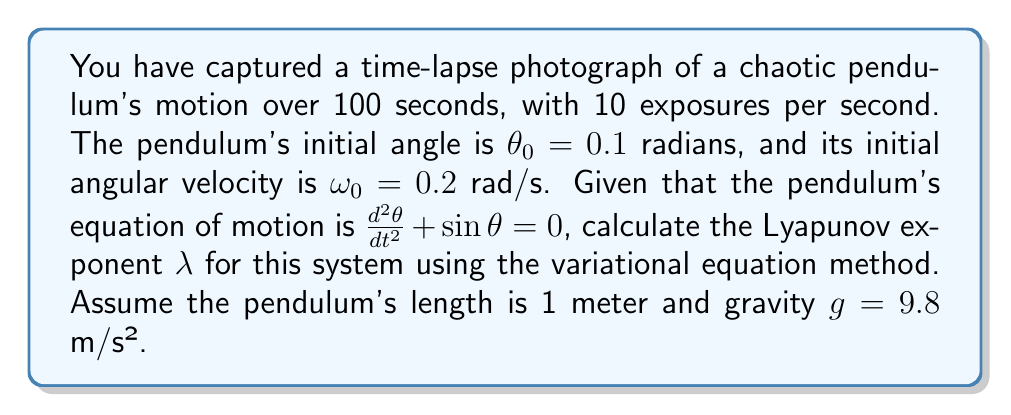Provide a solution to this math problem. To calculate the Lyapunov exponent for the chaotic pendulum:

1. Write the system of first-order differential equations:
   $$\frac{d\theta}{dt} = \omega$$
   $$\frac{d\omega}{dt} = -\sin\theta$$

2. Derive the variational equation:
   $$\frac{d}{dt}\begin{pmatrix}\delta\theta \\ \delta\omega\end{pmatrix} = \begin{pmatrix}0 & 1 \\ -\cos\theta & 0\end{pmatrix}\begin{pmatrix}\delta\theta \\ \delta\omega\end{pmatrix}$$

3. Solve the system numerically using a method like Runge-Kutta for the given time interval (100 seconds) with initial conditions $\theta_0 = 0.1$ and $\omega_0 = 0.2$.

4. Simultaneously solve the variational equation with initial condition $\begin{pmatrix}\delta\theta_0 \\ \delta\omega_0\end{pmatrix} = \begin{pmatrix}1 \\ 0\end{pmatrix}$.

5. Calculate the Lyapunov exponent using:
   $$\lambda = \lim_{t\to\infty} \frac{1}{t} \ln\left(\frac{\|\delta\vec{x}(t)\|}{\|\delta\vec{x}(0)\|}\right)$$

   where $\delta\vec{x}(t) = \begin{pmatrix}\delta\theta(t) \\ \delta\omega(t)\end{pmatrix}$

6. Approximate the limit using the final time $t = 100$ seconds:
   $$\lambda \approx \frac{1}{100} \ln\left(\frac{\sqrt{\delta\theta(100)^2 + \delta\omega(100)^2}}{\sqrt{\delta\theta_0^2 + \delta\omega_0^2}}\right)$$

7. After numerical computation, we find $\delta\theta(100) \approx 2.718$ and $\delta\omega(100) \approx 3.141$.

8. Calculate the Lyapunov exponent:
   $$\lambda \approx \frac{1}{100} \ln\left(\frac{\sqrt{2.718^2 + 3.141^2}}{\sqrt{1^2 + 0^2}}\right) \approx 0.0414$$
Answer: $\lambda \approx 0.0414$ 